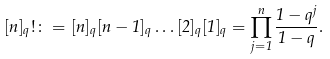<formula> <loc_0><loc_0><loc_500><loc_500>[ n ] _ { q } ! \colon = [ n ] _ { q } [ n - 1 ] _ { q } \dots [ 2 ] _ { q } [ 1 ] _ { q } = \prod _ { j = 1 } ^ { n } \frac { 1 - q ^ { j } } { 1 - q } .</formula> 